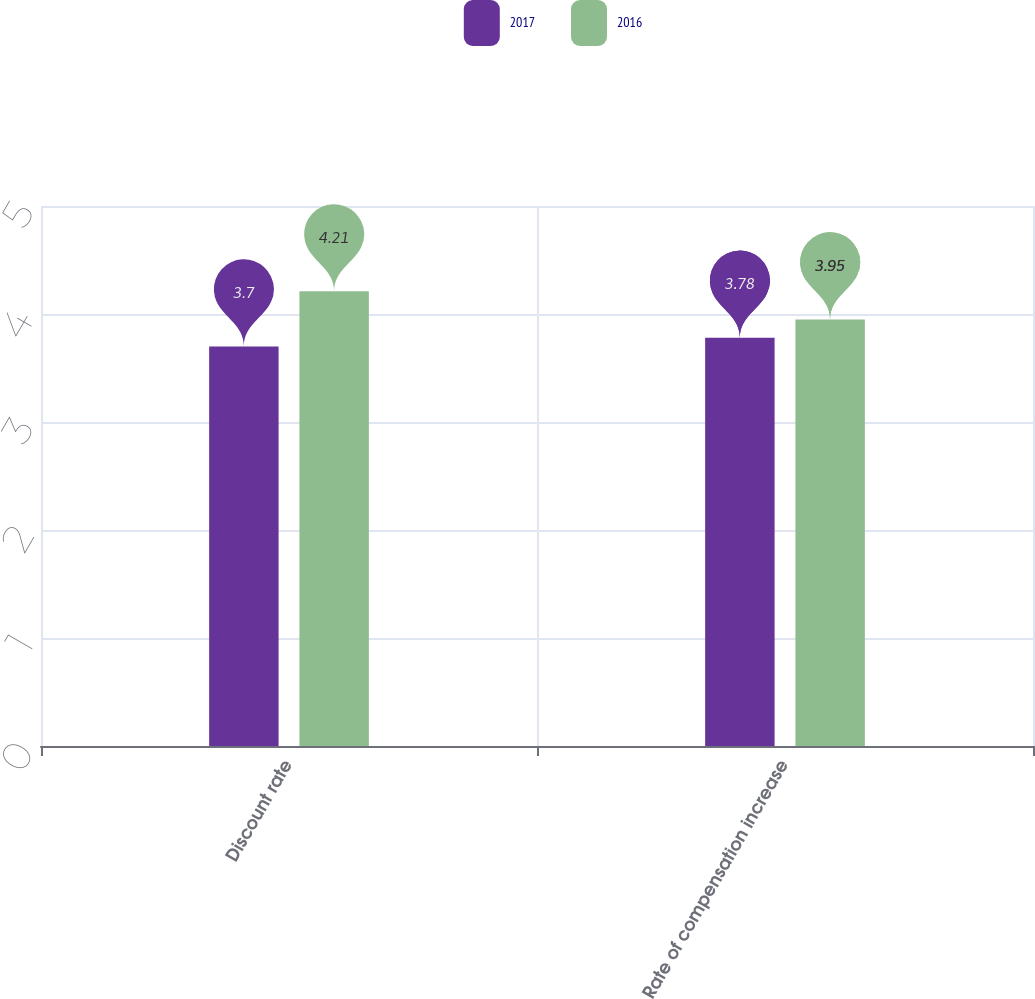Convert chart. <chart><loc_0><loc_0><loc_500><loc_500><stacked_bar_chart><ecel><fcel>Discount rate<fcel>Rate of compensation increase<nl><fcel>2017<fcel>3.7<fcel>3.78<nl><fcel>2016<fcel>4.21<fcel>3.95<nl></chart> 